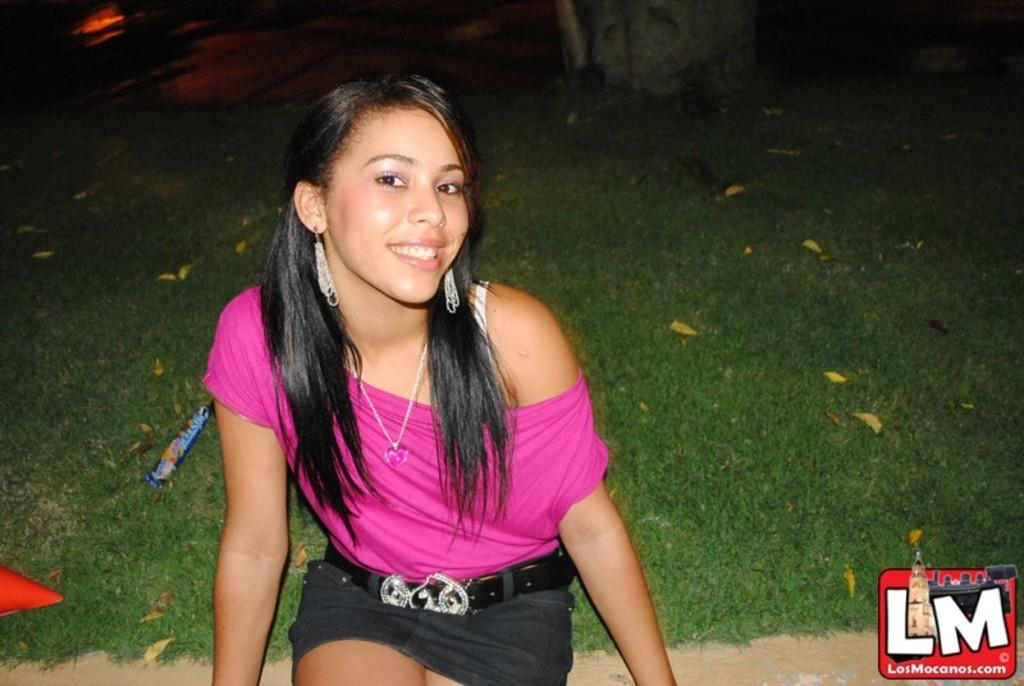What is the girl in the image doing? The girl is sitting in the image. What type of surface is the girl sitting on? The ground is covered with grass in the image. What else can be seen on the ground in the image? Leaves and objects are present on the ground in the image. Is there any text or marking in the image? Yes, there is a watermark in the bottom right corner of the image. What type of trouble is the girl causing in the library in the image? There is no library or trouble mentioned in the image; it only shows a girl sitting on grass with leaves and objects on the ground. What kind of doll is sitting next to the girl in the image? There is no doll present in the image; it only shows a girl sitting on grass with leaves and objects on the ground. 